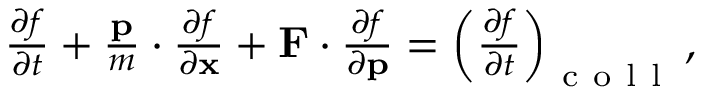Convert formula to latex. <formula><loc_0><loc_0><loc_500><loc_500>\begin{array} { r } { \frac { \partial f } { \partial t } + \frac { p } { m } \cdot \frac { \partial f } { \partial x } + F \cdot \frac { \partial f } { \partial p } = \left ( \frac { \partial f } { \partial t } \right ) _ { c o l l } , } \end{array}</formula> 